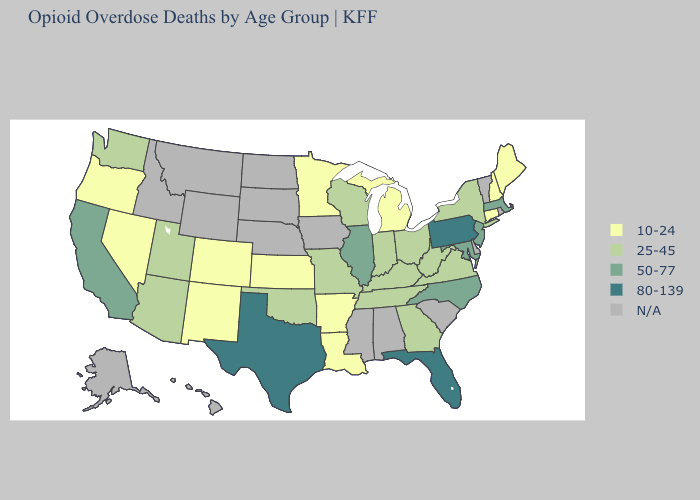What is the lowest value in the USA?
Short answer required. 10-24. Does Connecticut have the highest value in the Northeast?
Quick response, please. No. Is the legend a continuous bar?
Quick response, please. No. Name the states that have a value in the range 80-139?
Keep it brief. Florida, Pennsylvania, Texas. What is the value of Idaho?
Be succinct. N/A. Which states have the highest value in the USA?
Concise answer only. Florida, Pennsylvania, Texas. What is the value of Ohio?
Give a very brief answer. 25-45. Which states have the lowest value in the USA?
Answer briefly. Arkansas, Colorado, Connecticut, Kansas, Louisiana, Maine, Michigan, Minnesota, Nevada, New Hampshire, New Mexico, Oregon. Does Florida have the highest value in the USA?
Keep it brief. Yes. What is the value of Oklahoma?
Give a very brief answer. 25-45. Is the legend a continuous bar?
Short answer required. No. Name the states that have a value in the range 25-45?
Keep it brief. Arizona, Georgia, Indiana, Kentucky, Missouri, New York, Ohio, Oklahoma, Tennessee, Utah, Virginia, Washington, West Virginia, Wisconsin. Does the first symbol in the legend represent the smallest category?
Answer briefly. Yes. 